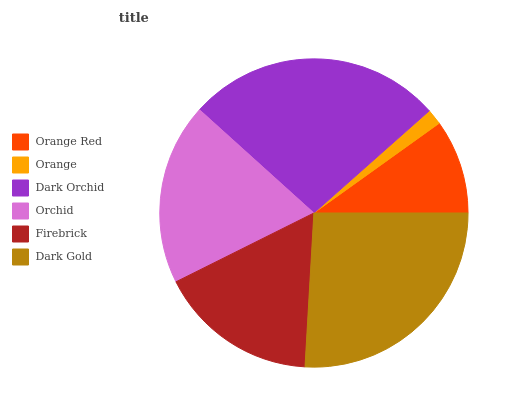Is Orange the minimum?
Answer yes or no. Yes. Is Dark Orchid the maximum?
Answer yes or no. Yes. Is Dark Orchid the minimum?
Answer yes or no. No. Is Orange the maximum?
Answer yes or no. No. Is Dark Orchid greater than Orange?
Answer yes or no. Yes. Is Orange less than Dark Orchid?
Answer yes or no. Yes. Is Orange greater than Dark Orchid?
Answer yes or no. No. Is Dark Orchid less than Orange?
Answer yes or no. No. Is Orchid the high median?
Answer yes or no. Yes. Is Firebrick the low median?
Answer yes or no. Yes. Is Orange Red the high median?
Answer yes or no. No. Is Dark Gold the low median?
Answer yes or no. No. 